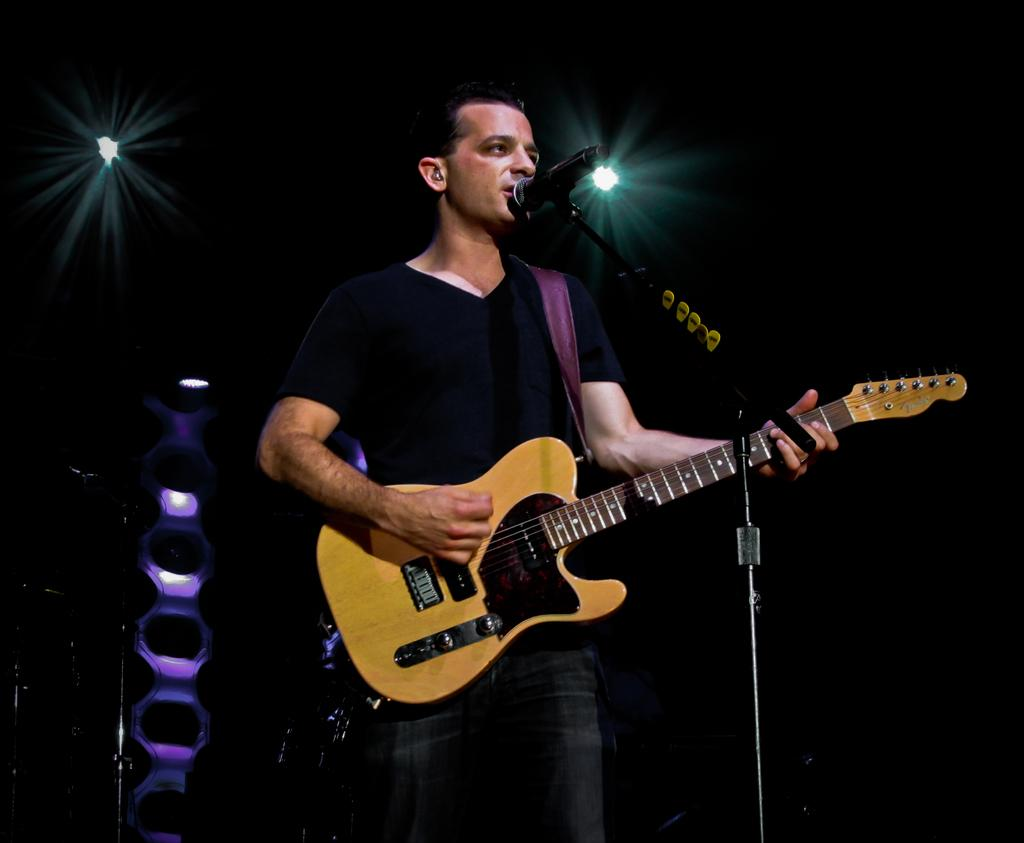Who is present in the image? There is a man in the image. What is the man doing in the image? The man is standing and holding a guitar with his hand. What object is in front of the man? There is a microphone in front of the man. What can be seen at the top of the image? There is a light at the top of the image. What are the man's hobbies, as indicated by the image? The image does not provide information about the man's hobbies; it only shows him holding a guitar and standing near a microphone. Is there any water visible in the image? No, there is no water visible in the image. 